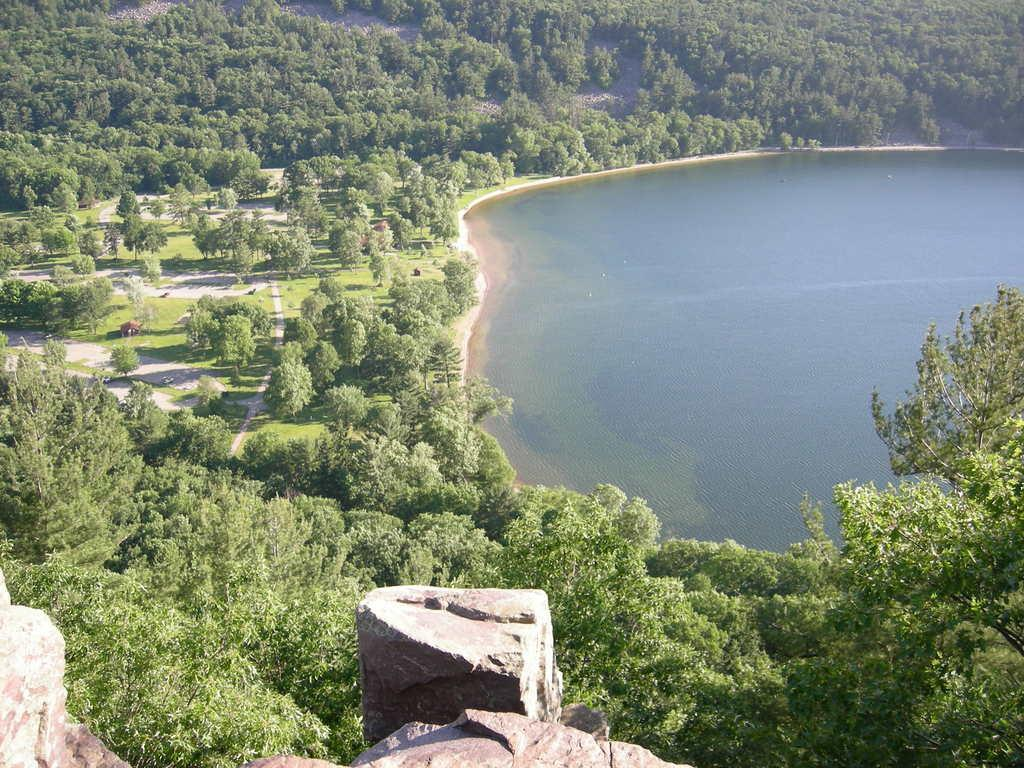What is the primary element visible in the image? There is water in the image. What type of vegetation can be seen in the image? There are trees, plants, and grass visible in the image. What is the ground like in the image? The ground is visible in the image is visible, and there are objects and stones present. Can you describe the objects on the ground? Unfortunately, the facts provided do not give specific details about the objects on the ground. What type of mist can be seen surrounding the house in the image? There is no house or mist present in the image; it features water, trees, plants, grass, objects on the ground, and stones at the bottom. 